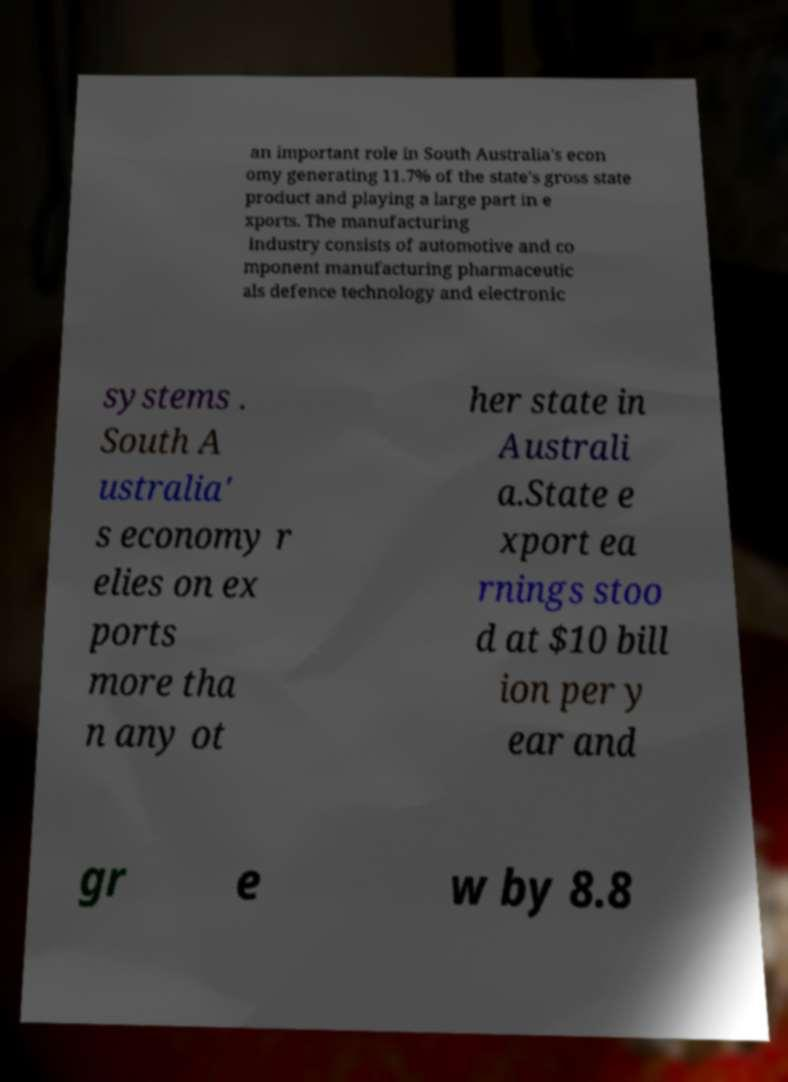I need the written content from this picture converted into text. Can you do that? an important role in South Australia's econ omy generating 11.7% of the state's gross state product and playing a large part in e xports. The manufacturing industry consists of automotive and co mponent manufacturing pharmaceutic als defence technology and electronic systems . South A ustralia' s economy r elies on ex ports more tha n any ot her state in Australi a.State e xport ea rnings stoo d at $10 bill ion per y ear and gr e w by 8.8 